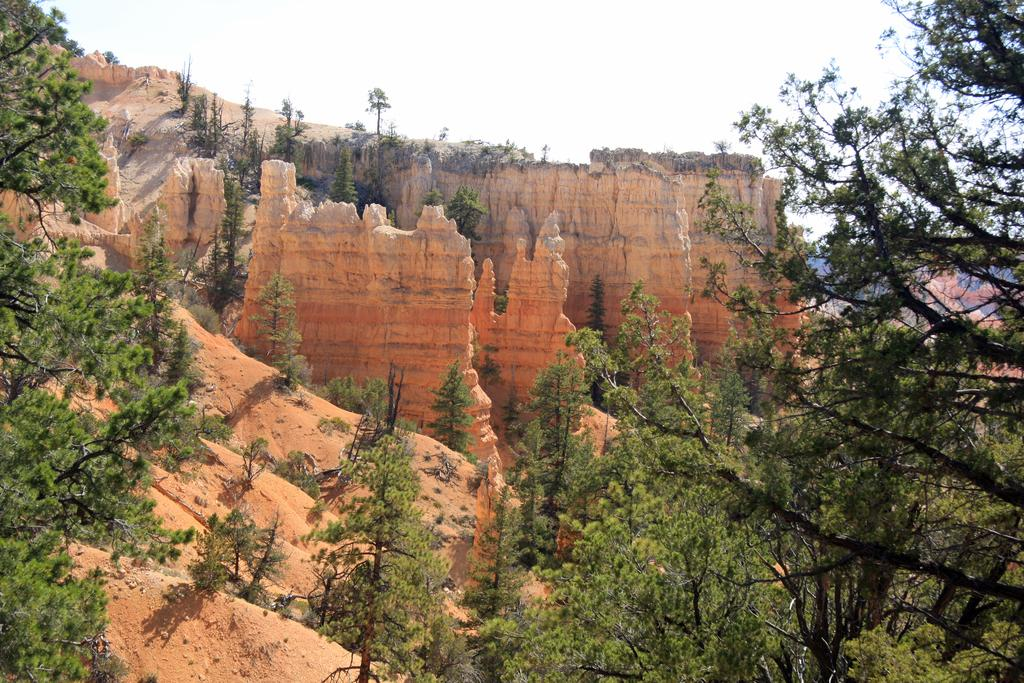What type of vegetation can be seen in the image? There are trees in the image. What geographical features are present in the image? There are hills in the middle of the image. What is visible at the top of the image? The sky is visible at the top of the image. How does the brake system work in the image? There is no brake system present in the image, as it features trees, hills, and the sky. What type of pain can be seen in the image? There is no pain visible in the image; it features natural elements such as trees, hills, and the sky. 